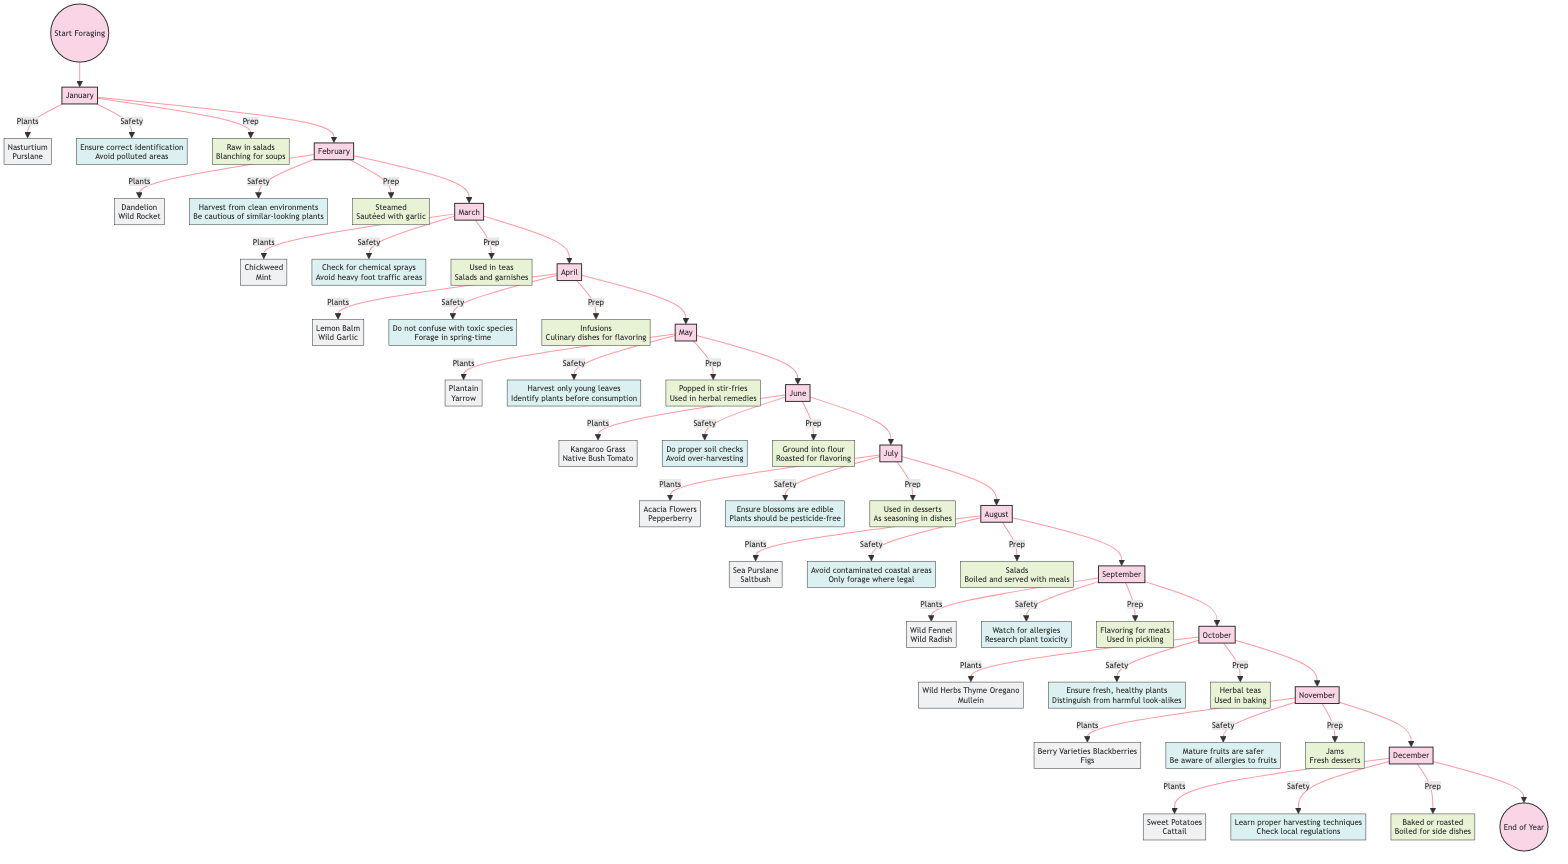What plants can be foraged in January? The diagram specifies that for January, the plants listed for foraging are Nasturtium and Purslane. This information is found in the January node connected to the start.
Answer: Nasturtium, Purslane What are the safety tips for foraging in July? In the July section of the diagram, the safety tips provided are to ensure that blossoms are edible and that the plants should be pesticide-free. This information is derived from the July node.
Answer: Ensure blossoms are edible, Plants should be pesticide-free How many months are listed in the foraging guide? The diagram features one node for each month from January to December. Counting these nodes yields a total of 12 months represented in the flowchart.
Answer: 12 Which month should you forage for Wild Garlic? According to the diagram, Wild Garlic can be foraged in April, as it is listed under the plants for that month. This information is easily accessible from the April node in the flowchart.
Answer: April What preparation methods are suggested for the plants in October? The October section of the diagram indicates preparation methods which include herbal teas and used in baking. This information can be found in the node corresponding to October.
Answer: Herbal teas, Used in baking What is the relationship between the plants listed in September and their safety tips? In the diagram, the plants in September are Wild Fennel and Wild Radish. Their safety tips include watching for allergies and researching plant toxicity, indicating the importance of safety in conjunction with the specific plants listed. This shows a direct connection between the two nodes for that month.
Answer: Watch for allergies, Research plant toxicity Which plants are foraged in December, and what is a safety tip for them? The December node lists Sweet Potatoes and Cattail as the foraged plants, with a safety tip that recommends learning proper harvesting techniques. This information is linked within the December section of the diagram.
Answer: Sweet Potatoes, Cattail; Learn proper harvesting techniques How many preparation methods are listed for the plants in June? For June, the diagram details two preparation methods: ground into flour and roasted for flavoring. These methods are specifically connected to the June node in the flowchart.
Answer: 2 In which month should you harvest Berry Varieties and what are the safety tips? The diagram specifies that Berry Varieties, particularly Blackberries and Figs, are to be harvested in November, with safety tips emphasizing that mature fruits are safer and awareness of allergies to fruits. This information is linked to the November node.
Answer: November; Mature fruits are safer, Be aware of allergies to fruits 